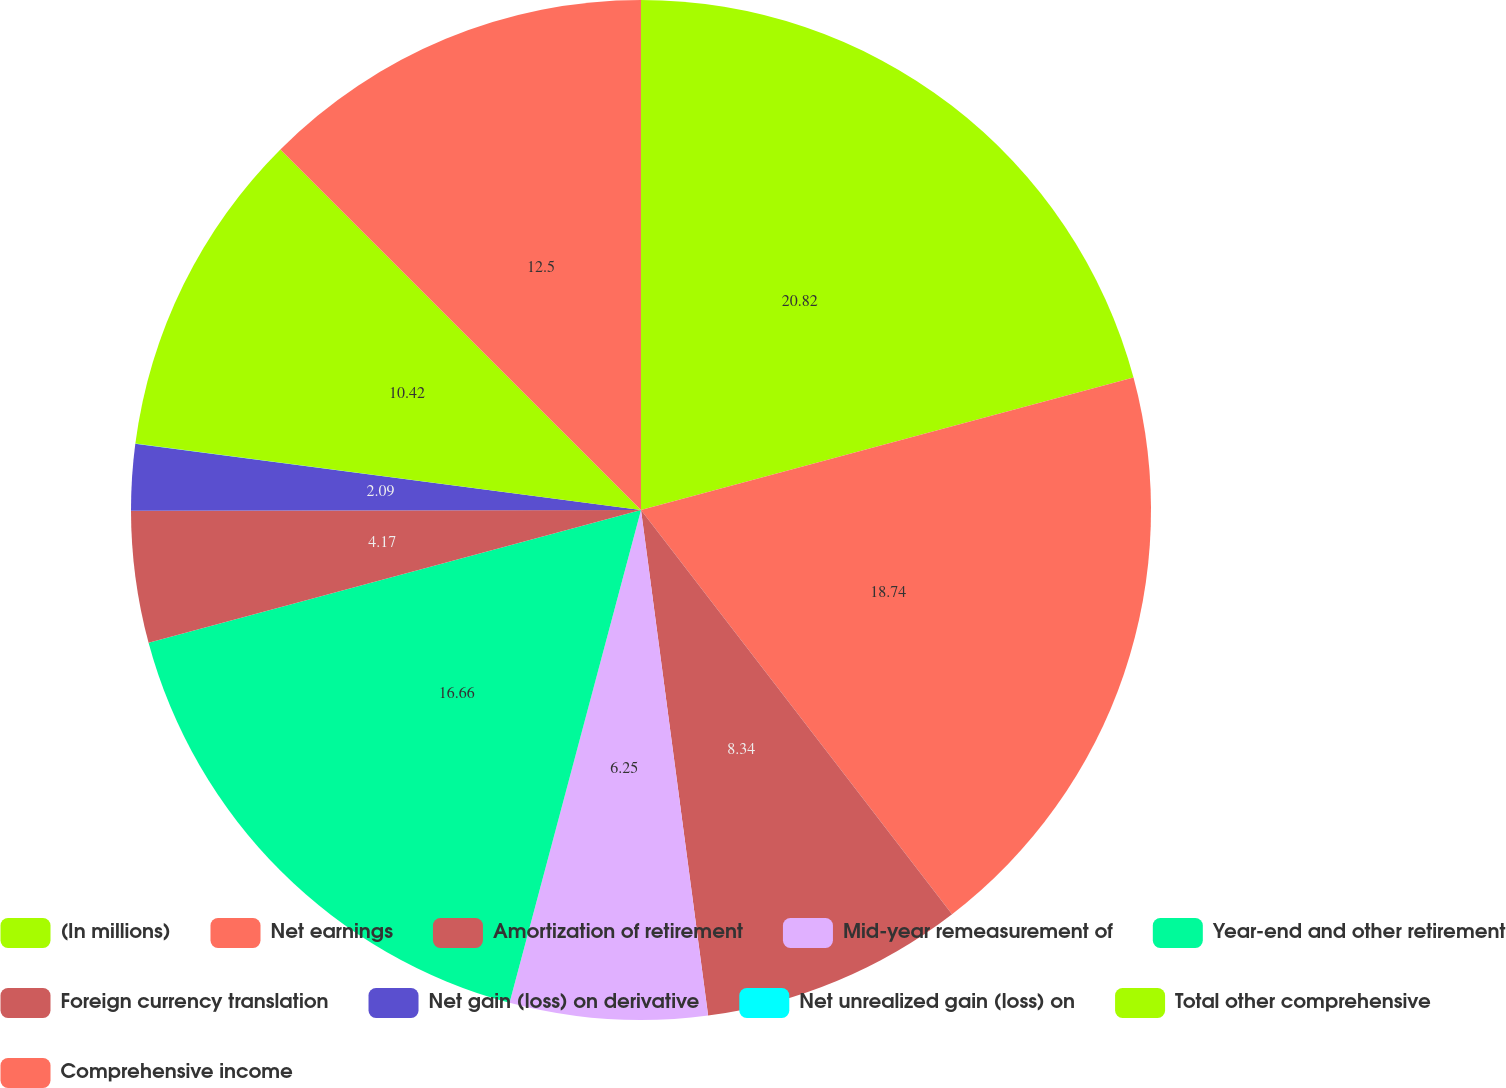Convert chart. <chart><loc_0><loc_0><loc_500><loc_500><pie_chart><fcel>(In millions)<fcel>Net earnings<fcel>Amortization of retirement<fcel>Mid-year remeasurement of<fcel>Year-end and other retirement<fcel>Foreign currency translation<fcel>Net gain (loss) on derivative<fcel>Net unrealized gain (loss) on<fcel>Total other comprehensive<fcel>Comprehensive income<nl><fcel>20.82%<fcel>18.74%<fcel>8.34%<fcel>6.25%<fcel>16.66%<fcel>4.17%<fcel>2.09%<fcel>0.01%<fcel>10.42%<fcel>12.5%<nl></chart> 